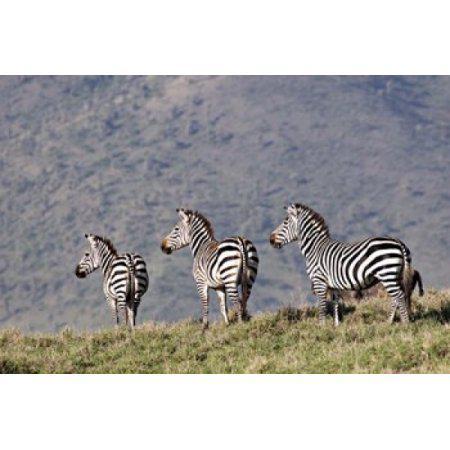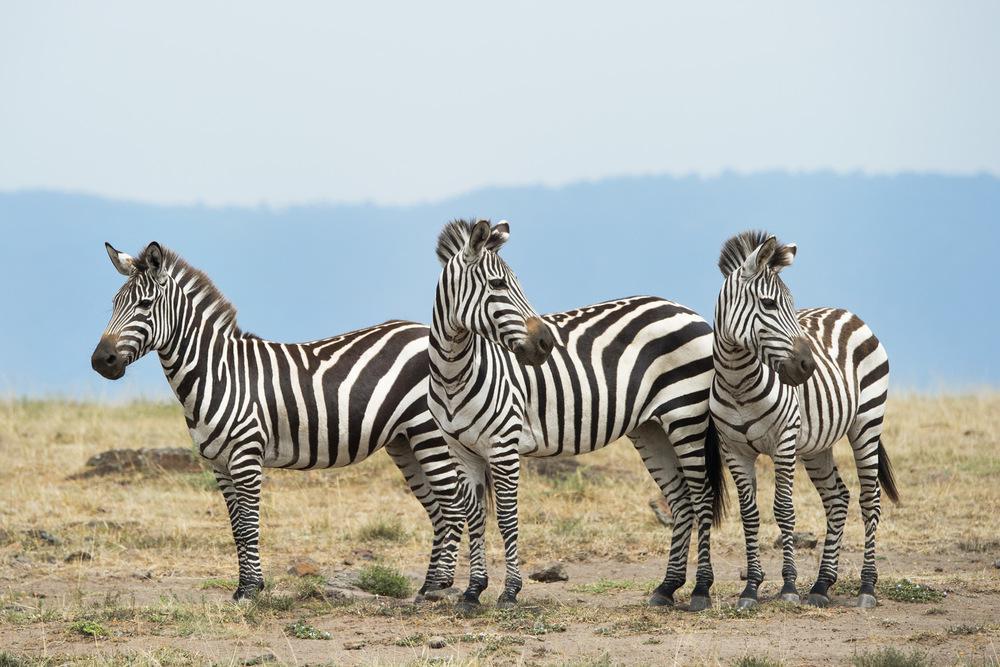The first image is the image on the left, the second image is the image on the right. Examine the images to the left and right. Is the description "In the right image, three zebras are heading right." accurate? Answer yes or no. No. 